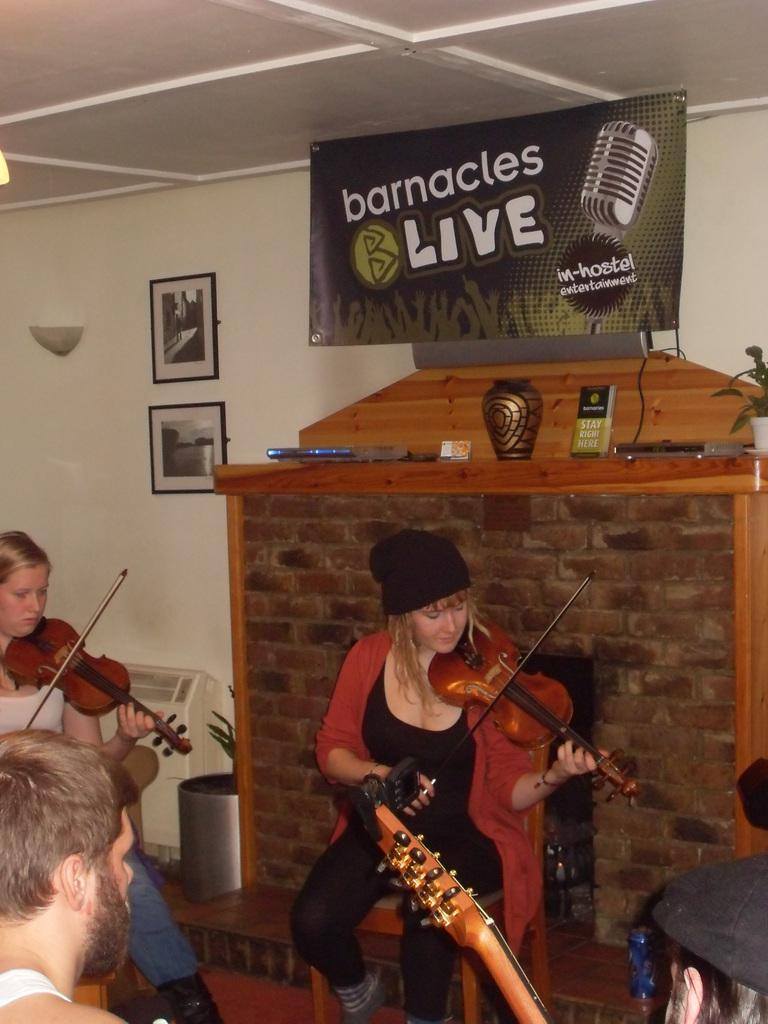How many people are present in the image? There are four people sitting in the image. What are the people holding in the image? The people are holding violins. What can be seen on the wall in the image? There is a wall with photo frames in the image. What other decorative item is present in the image? There is a poster in the image. What objects can be seen on the table in the image? There is a vase and a book in the image. What type of property is being discussed by the minister in the image? There is no minister or property present in the image; it features four people holding violins, a wall with photo frames, a poster, a vase, and a book. 